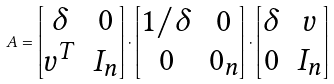Convert formula to latex. <formula><loc_0><loc_0><loc_500><loc_500>A = \begin{bmatrix} \delta & 0 \\ v ^ { T } & I _ { n } \end{bmatrix} \cdot \begin{bmatrix} 1 / \delta & 0 \\ 0 & { 0 _ { n } } \end{bmatrix} \cdot \begin{bmatrix} \delta & v \\ 0 & I _ { n } \end{bmatrix}</formula> 